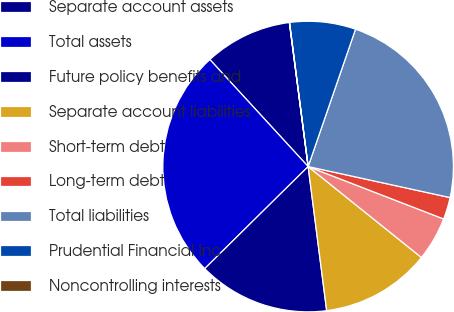<chart> <loc_0><loc_0><loc_500><loc_500><pie_chart><fcel>Separate account assets<fcel>Total assets<fcel>Future policy benefits and<fcel>Separate account liabilities<fcel>Short-term debt<fcel>Long-term debt<fcel>Total liabilities<fcel>Prudential Financial Inc<fcel>Noncontrolling interests<nl><fcel>9.76%<fcel>25.57%<fcel>14.64%<fcel>12.2%<fcel>4.89%<fcel>2.45%<fcel>23.14%<fcel>7.33%<fcel>0.02%<nl></chart> 